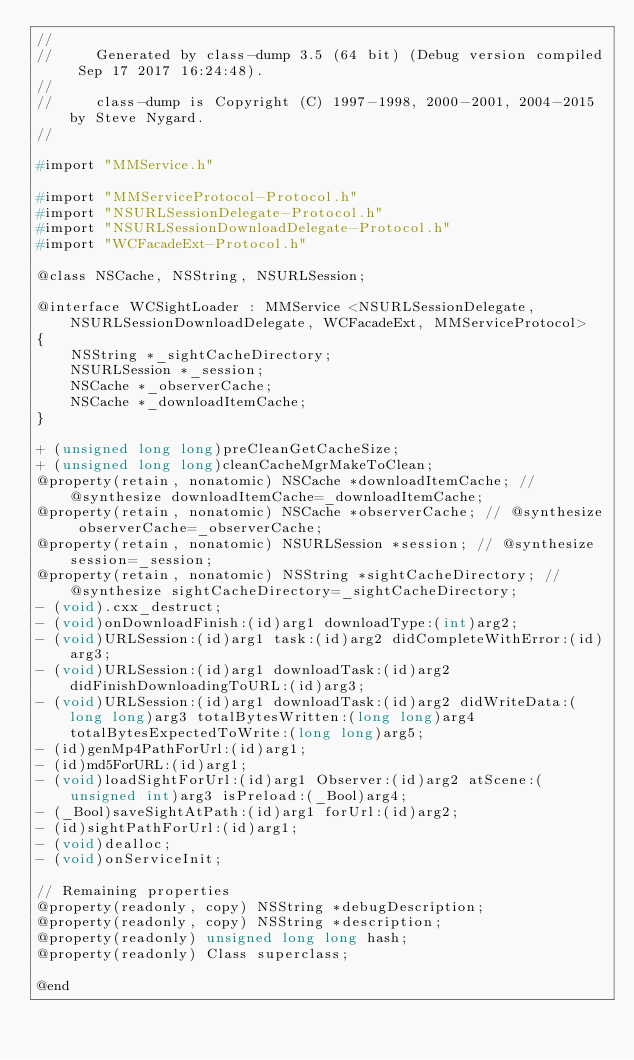<code> <loc_0><loc_0><loc_500><loc_500><_C_>//
//     Generated by class-dump 3.5 (64 bit) (Debug version compiled Sep 17 2017 16:24:48).
//
//     class-dump is Copyright (C) 1997-1998, 2000-2001, 2004-2015 by Steve Nygard.
//

#import "MMService.h"

#import "MMServiceProtocol-Protocol.h"
#import "NSURLSessionDelegate-Protocol.h"
#import "NSURLSessionDownloadDelegate-Protocol.h"
#import "WCFacadeExt-Protocol.h"

@class NSCache, NSString, NSURLSession;

@interface WCSightLoader : MMService <NSURLSessionDelegate, NSURLSessionDownloadDelegate, WCFacadeExt, MMServiceProtocol>
{
    NSString *_sightCacheDirectory;
    NSURLSession *_session;
    NSCache *_observerCache;
    NSCache *_downloadItemCache;
}

+ (unsigned long long)preCleanGetCacheSize;
+ (unsigned long long)cleanCacheMgrMakeToClean;
@property(retain, nonatomic) NSCache *downloadItemCache; // @synthesize downloadItemCache=_downloadItemCache;
@property(retain, nonatomic) NSCache *observerCache; // @synthesize observerCache=_observerCache;
@property(retain, nonatomic) NSURLSession *session; // @synthesize session=_session;
@property(retain, nonatomic) NSString *sightCacheDirectory; // @synthesize sightCacheDirectory=_sightCacheDirectory;
- (void).cxx_destruct;
- (void)onDownloadFinish:(id)arg1 downloadType:(int)arg2;
- (void)URLSession:(id)arg1 task:(id)arg2 didCompleteWithError:(id)arg3;
- (void)URLSession:(id)arg1 downloadTask:(id)arg2 didFinishDownloadingToURL:(id)arg3;
- (void)URLSession:(id)arg1 downloadTask:(id)arg2 didWriteData:(long long)arg3 totalBytesWritten:(long long)arg4 totalBytesExpectedToWrite:(long long)arg5;
- (id)genMp4PathForUrl:(id)arg1;
- (id)md5ForURL:(id)arg1;
- (void)loadSightForUrl:(id)arg1 Observer:(id)arg2 atScene:(unsigned int)arg3 isPreload:(_Bool)arg4;
- (_Bool)saveSightAtPath:(id)arg1 forUrl:(id)arg2;
- (id)sightPathForUrl:(id)arg1;
- (void)dealloc;
- (void)onServiceInit;

// Remaining properties
@property(readonly, copy) NSString *debugDescription;
@property(readonly, copy) NSString *description;
@property(readonly) unsigned long long hash;
@property(readonly) Class superclass;

@end

</code> 